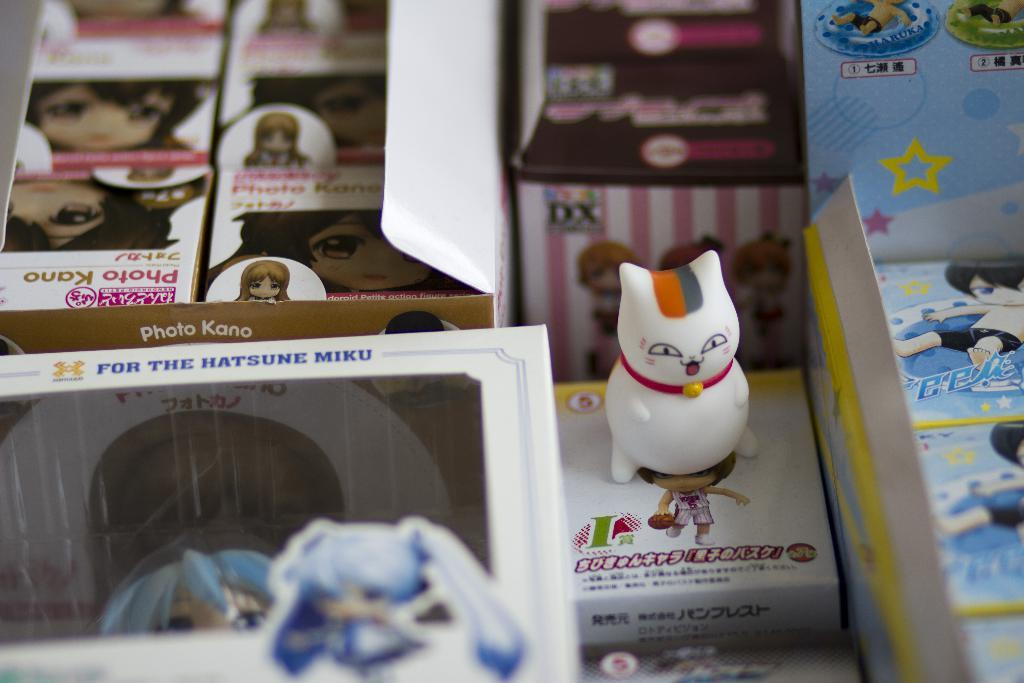<image>
Relay a brief, clear account of the picture shown. Boxes of Japanese things are shown including one about Hatsune Miku. 